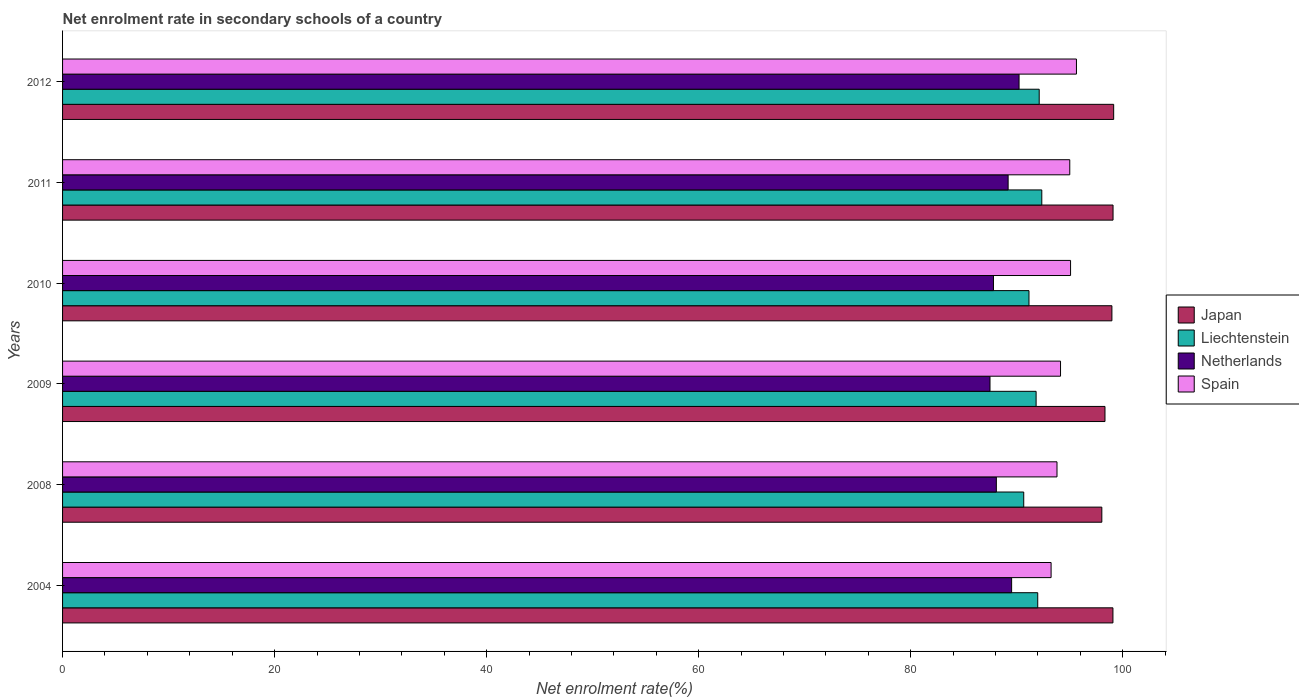How many different coloured bars are there?
Keep it short and to the point. 4. Are the number of bars per tick equal to the number of legend labels?
Ensure brevity in your answer.  Yes. How many bars are there on the 6th tick from the top?
Offer a terse response. 4. In how many cases, is the number of bars for a given year not equal to the number of legend labels?
Provide a short and direct response. 0. What is the net enrolment rate in secondary schools in Spain in 2008?
Give a very brief answer. 93.8. Across all years, what is the maximum net enrolment rate in secondary schools in Liechtenstein?
Make the answer very short. 92.36. Across all years, what is the minimum net enrolment rate in secondary schools in Netherlands?
Your answer should be very brief. 87.48. In which year was the net enrolment rate in secondary schools in Liechtenstein maximum?
Your answer should be compact. 2011. What is the total net enrolment rate in secondary schools in Netherlands in the graph?
Provide a short and direct response. 532.28. What is the difference between the net enrolment rate in secondary schools in Netherlands in 2009 and that in 2010?
Provide a succinct answer. -0.33. What is the difference between the net enrolment rate in secondary schools in Spain in 2004 and the net enrolment rate in secondary schools in Japan in 2011?
Your response must be concise. -5.84. What is the average net enrolment rate in secondary schools in Spain per year?
Offer a terse response. 94.48. In the year 2012, what is the difference between the net enrolment rate in secondary schools in Japan and net enrolment rate in secondary schools in Liechtenstein?
Provide a short and direct response. 7.02. What is the ratio of the net enrolment rate in secondary schools in Spain in 2004 to that in 2010?
Ensure brevity in your answer.  0.98. What is the difference between the highest and the second highest net enrolment rate in secondary schools in Liechtenstein?
Your answer should be very brief. 0.24. What is the difference between the highest and the lowest net enrolment rate in secondary schools in Netherlands?
Provide a short and direct response. 2.74. In how many years, is the net enrolment rate in secondary schools in Japan greater than the average net enrolment rate in secondary schools in Japan taken over all years?
Your answer should be compact. 4. Is it the case that in every year, the sum of the net enrolment rate in secondary schools in Japan and net enrolment rate in secondary schools in Liechtenstein is greater than the sum of net enrolment rate in secondary schools in Netherlands and net enrolment rate in secondary schools in Spain?
Make the answer very short. Yes. What does the 2nd bar from the bottom in 2010 represents?
Provide a succinct answer. Liechtenstein. Is it the case that in every year, the sum of the net enrolment rate in secondary schools in Liechtenstein and net enrolment rate in secondary schools in Spain is greater than the net enrolment rate in secondary schools in Japan?
Provide a succinct answer. Yes. How many bars are there?
Offer a terse response. 24. Are all the bars in the graph horizontal?
Provide a short and direct response. Yes. How many years are there in the graph?
Your answer should be very brief. 6. Are the values on the major ticks of X-axis written in scientific E-notation?
Provide a succinct answer. No. Does the graph contain any zero values?
Provide a short and direct response. No. Does the graph contain grids?
Keep it short and to the point. No. What is the title of the graph?
Your answer should be compact. Net enrolment rate in secondary schools of a country. What is the label or title of the X-axis?
Give a very brief answer. Net enrolment rate(%). What is the Net enrolment rate(%) of Japan in 2004?
Provide a succinct answer. 99.07. What is the Net enrolment rate(%) in Liechtenstein in 2004?
Provide a succinct answer. 91.98. What is the Net enrolment rate(%) in Netherlands in 2004?
Keep it short and to the point. 89.52. What is the Net enrolment rate(%) of Spain in 2004?
Ensure brevity in your answer.  93.24. What is the Net enrolment rate(%) in Japan in 2008?
Offer a terse response. 98.03. What is the Net enrolment rate(%) of Liechtenstein in 2008?
Give a very brief answer. 90.66. What is the Net enrolment rate(%) of Netherlands in 2008?
Offer a terse response. 88.08. What is the Net enrolment rate(%) in Spain in 2008?
Make the answer very short. 93.8. What is the Net enrolment rate(%) of Japan in 2009?
Keep it short and to the point. 98.32. What is the Net enrolment rate(%) of Liechtenstein in 2009?
Offer a terse response. 91.83. What is the Net enrolment rate(%) of Netherlands in 2009?
Keep it short and to the point. 87.48. What is the Net enrolment rate(%) of Spain in 2009?
Make the answer very short. 94.13. What is the Net enrolment rate(%) of Japan in 2010?
Provide a short and direct response. 98.98. What is the Net enrolment rate(%) of Liechtenstein in 2010?
Your answer should be compact. 91.15. What is the Net enrolment rate(%) in Netherlands in 2010?
Provide a short and direct response. 87.8. What is the Net enrolment rate(%) in Spain in 2010?
Keep it short and to the point. 95.08. What is the Net enrolment rate(%) of Japan in 2011?
Provide a short and direct response. 99.08. What is the Net enrolment rate(%) of Liechtenstein in 2011?
Make the answer very short. 92.36. What is the Net enrolment rate(%) in Netherlands in 2011?
Ensure brevity in your answer.  89.19. What is the Net enrolment rate(%) in Spain in 2011?
Your answer should be very brief. 95. What is the Net enrolment rate(%) of Japan in 2012?
Your response must be concise. 99.14. What is the Net enrolment rate(%) in Liechtenstein in 2012?
Give a very brief answer. 92.12. What is the Net enrolment rate(%) in Netherlands in 2012?
Give a very brief answer. 90.22. What is the Net enrolment rate(%) in Spain in 2012?
Provide a short and direct response. 95.63. Across all years, what is the maximum Net enrolment rate(%) in Japan?
Keep it short and to the point. 99.14. Across all years, what is the maximum Net enrolment rate(%) in Liechtenstein?
Your answer should be very brief. 92.36. Across all years, what is the maximum Net enrolment rate(%) in Netherlands?
Give a very brief answer. 90.22. Across all years, what is the maximum Net enrolment rate(%) of Spain?
Offer a terse response. 95.63. Across all years, what is the minimum Net enrolment rate(%) in Japan?
Ensure brevity in your answer.  98.03. Across all years, what is the minimum Net enrolment rate(%) in Liechtenstein?
Your answer should be very brief. 90.66. Across all years, what is the minimum Net enrolment rate(%) in Netherlands?
Your answer should be compact. 87.48. Across all years, what is the minimum Net enrolment rate(%) in Spain?
Your answer should be compact. 93.24. What is the total Net enrolment rate(%) of Japan in the graph?
Keep it short and to the point. 592.62. What is the total Net enrolment rate(%) in Liechtenstein in the graph?
Your answer should be compact. 550.1. What is the total Net enrolment rate(%) of Netherlands in the graph?
Provide a short and direct response. 532.28. What is the total Net enrolment rate(%) in Spain in the graph?
Your response must be concise. 566.88. What is the difference between the Net enrolment rate(%) of Japan in 2004 and that in 2008?
Make the answer very short. 1.05. What is the difference between the Net enrolment rate(%) of Liechtenstein in 2004 and that in 2008?
Your response must be concise. 1.32. What is the difference between the Net enrolment rate(%) of Netherlands in 2004 and that in 2008?
Make the answer very short. 1.44. What is the difference between the Net enrolment rate(%) in Spain in 2004 and that in 2008?
Ensure brevity in your answer.  -0.56. What is the difference between the Net enrolment rate(%) in Japan in 2004 and that in 2009?
Your response must be concise. 0.75. What is the difference between the Net enrolment rate(%) of Liechtenstein in 2004 and that in 2009?
Provide a succinct answer. 0.15. What is the difference between the Net enrolment rate(%) in Netherlands in 2004 and that in 2009?
Offer a terse response. 2.04. What is the difference between the Net enrolment rate(%) of Spain in 2004 and that in 2009?
Make the answer very short. -0.89. What is the difference between the Net enrolment rate(%) in Japan in 2004 and that in 2010?
Your response must be concise. 0.1. What is the difference between the Net enrolment rate(%) in Liechtenstein in 2004 and that in 2010?
Your answer should be very brief. 0.83. What is the difference between the Net enrolment rate(%) in Netherlands in 2004 and that in 2010?
Provide a short and direct response. 1.71. What is the difference between the Net enrolment rate(%) of Spain in 2004 and that in 2010?
Your answer should be very brief. -1.84. What is the difference between the Net enrolment rate(%) in Japan in 2004 and that in 2011?
Your response must be concise. -0.01. What is the difference between the Net enrolment rate(%) of Liechtenstein in 2004 and that in 2011?
Ensure brevity in your answer.  -0.38. What is the difference between the Net enrolment rate(%) in Netherlands in 2004 and that in 2011?
Your answer should be very brief. 0.33. What is the difference between the Net enrolment rate(%) in Spain in 2004 and that in 2011?
Your answer should be very brief. -1.76. What is the difference between the Net enrolment rate(%) in Japan in 2004 and that in 2012?
Keep it short and to the point. -0.07. What is the difference between the Net enrolment rate(%) in Liechtenstein in 2004 and that in 2012?
Make the answer very short. -0.14. What is the difference between the Net enrolment rate(%) in Netherlands in 2004 and that in 2012?
Your answer should be very brief. -0.7. What is the difference between the Net enrolment rate(%) of Spain in 2004 and that in 2012?
Offer a very short reply. -2.39. What is the difference between the Net enrolment rate(%) of Japan in 2008 and that in 2009?
Keep it short and to the point. -0.3. What is the difference between the Net enrolment rate(%) of Liechtenstein in 2008 and that in 2009?
Your response must be concise. -1.17. What is the difference between the Net enrolment rate(%) in Netherlands in 2008 and that in 2009?
Provide a succinct answer. 0.6. What is the difference between the Net enrolment rate(%) of Spain in 2008 and that in 2009?
Provide a short and direct response. -0.33. What is the difference between the Net enrolment rate(%) in Japan in 2008 and that in 2010?
Your response must be concise. -0.95. What is the difference between the Net enrolment rate(%) of Liechtenstein in 2008 and that in 2010?
Ensure brevity in your answer.  -0.49. What is the difference between the Net enrolment rate(%) in Netherlands in 2008 and that in 2010?
Keep it short and to the point. 0.27. What is the difference between the Net enrolment rate(%) in Spain in 2008 and that in 2010?
Offer a terse response. -1.28. What is the difference between the Net enrolment rate(%) in Japan in 2008 and that in 2011?
Offer a very short reply. -1.06. What is the difference between the Net enrolment rate(%) in Liechtenstein in 2008 and that in 2011?
Give a very brief answer. -1.7. What is the difference between the Net enrolment rate(%) of Netherlands in 2008 and that in 2011?
Ensure brevity in your answer.  -1.11. What is the difference between the Net enrolment rate(%) in Spain in 2008 and that in 2011?
Make the answer very short. -1.21. What is the difference between the Net enrolment rate(%) in Japan in 2008 and that in 2012?
Your answer should be compact. -1.12. What is the difference between the Net enrolment rate(%) of Liechtenstein in 2008 and that in 2012?
Your answer should be very brief. -1.46. What is the difference between the Net enrolment rate(%) of Netherlands in 2008 and that in 2012?
Give a very brief answer. -2.14. What is the difference between the Net enrolment rate(%) of Spain in 2008 and that in 2012?
Ensure brevity in your answer.  -1.84. What is the difference between the Net enrolment rate(%) in Japan in 2009 and that in 2010?
Your answer should be very brief. -0.65. What is the difference between the Net enrolment rate(%) in Liechtenstein in 2009 and that in 2010?
Ensure brevity in your answer.  0.67. What is the difference between the Net enrolment rate(%) of Netherlands in 2009 and that in 2010?
Offer a terse response. -0.33. What is the difference between the Net enrolment rate(%) in Spain in 2009 and that in 2010?
Provide a succinct answer. -0.95. What is the difference between the Net enrolment rate(%) in Japan in 2009 and that in 2011?
Make the answer very short. -0.76. What is the difference between the Net enrolment rate(%) in Liechtenstein in 2009 and that in 2011?
Make the answer very short. -0.54. What is the difference between the Net enrolment rate(%) in Netherlands in 2009 and that in 2011?
Ensure brevity in your answer.  -1.71. What is the difference between the Net enrolment rate(%) in Spain in 2009 and that in 2011?
Your answer should be very brief. -0.87. What is the difference between the Net enrolment rate(%) in Japan in 2009 and that in 2012?
Give a very brief answer. -0.82. What is the difference between the Net enrolment rate(%) in Liechtenstein in 2009 and that in 2012?
Keep it short and to the point. -0.29. What is the difference between the Net enrolment rate(%) in Netherlands in 2009 and that in 2012?
Keep it short and to the point. -2.74. What is the difference between the Net enrolment rate(%) of Spain in 2009 and that in 2012?
Provide a succinct answer. -1.5. What is the difference between the Net enrolment rate(%) in Japan in 2010 and that in 2011?
Your answer should be compact. -0.11. What is the difference between the Net enrolment rate(%) of Liechtenstein in 2010 and that in 2011?
Provide a short and direct response. -1.21. What is the difference between the Net enrolment rate(%) of Netherlands in 2010 and that in 2011?
Make the answer very short. -1.38. What is the difference between the Net enrolment rate(%) of Spain in 2010 and that in 2011?
Make the answer very short. 0.07. What is the difference between the Net enrolment rate(%) in Japan in 2010 and that in 2012?
Provide a succinct answer. -0.17. What is the difference between the Net enrolment rate(%) in Liechtenstein in 2010 and that in 2012?
Ensure brevity in your answer.  -0.96. What is the difference between the Net enrolment rate(%) of Netherlands in 2010 and that in 2012?
Your response must be concise. -2.41. What is the difference between the Net enrolment rate(%) of Spain in 2010 and that in 2012?
Your response must be concise. -0.56. What is the difference between the Net enrolment rate(%) of Japan in 2011 and that in 2012?
Your answer should be very brief. -0.06. What is the difference between the Net enrolment rate(%) of Liechtenstein in 2011 and that in 2012?
Make the answer very short. 0.24. What is the difference between the Net enrolment rate(%) in Netherlands in 2011 and that in 2012?
Provide a short and direct response. -1.03. What is the difference between the Net enrolment rate(%) in Spain in 2011 and that in 2012?
Keep it short and to the point. -0.63. What is the difference between the Net enrolment rate(%) in Japan in 2004 and the Net enrolment rate(%) in Liechtenstein in 2008?
Provide a short and direct response. 8.41. What is the difference between the Net enrolment rate(%) of Japan in 2004 and the Net enrolment rate(%) of Netherlands in 2008?
Provide a short and direct response. 11. What is the difference between the Net enrolment rate(%) in Japan in 2004 and the Net enrolment rate(%) in Spain in 2008?
Ensure brevity in your answer.  5.28. What is the difference between the Net enrolment rate(%) of Liechtenstein in 2004 and the Net enrolment rate(%) of Netherlands in 2008?
Provide a succinct answer. 3.9. What is the difference between the Net enrolment rate(%) of Liechtenstein in 2004 and the Net enrolment rate(%) of Spain in 2008?
Keep it short and to the point. -1.82. What is the difference between the Net enrolment rate(%) of Netherlands in 2004 and the Net enrolment rate(%) of Spain in 2008?
Your answer should be very brief. -4.28. What is the difference between the Net enrolment rate(%) of Japan in 2004 and the Net enrolment rate(%) of Liechtenstein in 2009?
Your response must be concise. 7.25. What is the difference between the Net enrolment rate(%) of Japan in 2004 and the Net enrolment rate(%) of Netherlands in 2009?
Provide a succinct answer. 11.6. What is the difference between the Net enrolment rate(%) in Japan in 2004 and the Net enrolment rate(%) in Spain in 2009?
Provide a succinct answer. 4.94. What is the difference between the Net enrolment rate(%) in Liechtenstein in 2004 and the Net enrolment rate(%) in Netherlands in 2009?
Give a very brief answer. 4.5. What is the difference between the Net enrolment rate(%) of Liechtenstein in 2004 and the Net enrolment rate(%) of Spain in 2009?
Give a very brief answer. -2.15. What is the difference between the Net enrolment rate(%) of Netherlands in 2004 and the Net enrolment rate(%) of Spain in 2009?
Make the answer very short. -4.61. What is the difference between the Net enrolment rate(%) of Japan in 2004 and the Net enrolment rate(%) of Liechtenstein in 2010?
Your response must be concise. 7.92. What is the difference between the Net enrolment rate(%) of Japan in 2004 and the Net enrolment rate(%) of Netherlands in 2010?
Your answer should be compact. 11.27. What is the difference between the Net enrolment rate(%) of Japan in 2004 and the Net enrolment rate(%) of Spain in 2010?
Your answer should be very brief. 4. What is the difference between the Net enrolment rate(%) in Liechtenstein in 2004 and the Net enrolment rate(%) in Netherlands in 2010?
Provide a succinct answer. 4.18. What is the difference between the Net enrolment rate(%) in Liechtenstein in 2004 and the Net enrolment rate(%) in Spain in 2010?
Offer a very short reply. -3.1. What is the difference between the Net enrolment rate(%) in Netherlands in 2004 and the Net enrolment rate(%) in Spain in 2010?
Your response must be concise. -5.56. What is the difference between the Net enrolment rate(%) of Japan in 2004 and the Net enrolment rate(%) of Liechtenstein in 2011?
Ensure brevity in your answer.  6.71. What is the difference between the Net enrolment rate(%) in Japan in 2004 and the Net enrolment rate(%) in Netherlands in 2011?
Your response must be concise. 9.89. What is the difference between the Net enrolment rate(%) of Japan in 2004 and the Net enrolment rate(%) of Spain in 2011?
Provide a succinct answer. 4.07. What is the difference between the Net enrolment rate(%) in Liechtenstein in 2004 and the Net enrolment rate(%) in Netherlands in 2011?
Your answer should be compact. 2.79. What is the difference between the Net enrolment rate(%) in Liechtenstein in 2004 and the Net enrolment rate(%) in Spain in 2011?
Provide a succinct answer. -3.02. What is the difference between the Net enrolment rate(%) of Netherlands in 2004 and the Net enrolment rate(%) of Spain in 2011?
Provide a short and direct response. -5.48. What is the difference between the Net enrolment rate(%) in Japan in 2004 and the Net enrolment rate(%) in Liechtenstein in 2012?
Provide a succinct answer. 6.96. What is the difference between the Net enrolment rate(%) of Japan in 2004 and the Net enrolment rate(%) of Netherlands in 2012?
Make the answer very short. 8.86. What is the difference between the Net enrolment rate(%) of Japan in 2004 and the Net enrolment rate(%) of Spain in 2012?
Ensure brevity in your answer.  3.44. What is the difference between the Net enrolment rate(%) of Liechtenstein in 2004 and the Net enrolment rate(%) of Netherlands in 2012?
Your answer should be compact. 1.76. What is the difference between the Net enrolment rate(%) of Liechtenstein in 2004 and the Net enrolment rate(%) of Spain in 2012?
Your answer should be compact. -3.65. What is the difference between the Net enrolment rate(%) in Netherlands in 2004 and the Net enrolment rate(%) in Spain in 2012?
Keep it short and to the point. -6.11. What is the difference between the Net enrolment rate(%) in Japan in 2008 and the Net enrolment rate(%) in Liechtenstein in 2009?
Offer a terse response. 6.2. What is the difference between the Net enrolment rate(%) in Japan in 2008 and the Net enrolment rate(%) in Netherlands in 2009?
Provide a succinct answer. 10.55. What is the difference between the Net enrolment rate(%) in Japan in 2008 and the Net enrolment rate(%) in Spain in 2009?
Offer a very short reply. 3.9. What is the difference between the Net enrolment rate(%) of Liechtenstein in 2008 and the Net enrolment rate(%) of Netherlands in 2009?
Provide a succinct answer. 3.18. What is the difference between the Net enrolment rate(%) in Liechtenstein in 2008 and the Net enrolment rate(%) in Spain in 2009?
Keep it short and to the point. -3.47. What is the difference between the Net enrolment rate(%) in Netherlands in 2008 and the Net enrolment rate(%) in Spain in 2009?
Give a very brief answer. -6.05. What is the difference between the Net enrolment rate(%) of Japan in 2008 and the Net enrolment rate(%) of Liechtenstein in 2010?
Your answer should be very brief. 6.87. What is the difference between the Net enrolment rate(%) in Japan in 2008 and the Net enrolment rate(%) in Netherlands in 2010?
Ensure brevity in your answer.  10.22. What is the difference between the Net enrolment rate(%) in Japan in 2008 and the Net enrolment rate(%) in Spain in 2010?
Provide a succinct answer. 2.95. What is the difference between the Net enrolment rate(%) of Liechtenstein in 2008 and the Net enrolment rate(%) of Netherlands in 2010?
Make the answer very short. 2.86. What is the difference between the Net enrolment rate(%) in Liechtenstein in 2008 and the Net enrolment rate(%) in Spain in 2010?
Your response must be concise. -4.42. What is the difference between the Net enrolment rate(%) in Netherlands in 2008 and the Net enrolment rate(%) in Spain in 2010?
Offer a terse response. -7. What is the difference between the Net enrolment rate(%) in Japan in 2008 and the Net enrolment rate(%) in Liechtenstein in 2011?
Your response must be concise. 5.66. What is the difference between the Net enrolment rate(%) in Japan in 2008 and the Net enrolment rate(%) in Netherlands in 2011?
Give a very brief answer. 8.84. What is the difference between the Net enrolment rate(%) in Japan in 2008 and the Net enrolment rate(%) in Spain in 2011?
Your response must be concise. 3.02. What is the difference between the Net enrolment rate(%) of Liechtenstein in 2008 and the Net enrolment rate(%) of Netherlands in 2011?
Provide a short and direct response. 1.47. What is the difference between the Net enrolment rate(%) in Liechtenstein in 2008 and the Net enrolment rate(%) in Spain in 2011?
Offer a very short reply. -4.34. What is the difference between the Net enrolment rate(%) of Netherlands in 2008 and the Net enrolment rate(%) of Spain in 2011?
Provide a succinct answer. -6.93. What is the difference between the Net enrolment rate(%) in Japan in 2008 and the Net enrolment rate(%) in Liechtenstein in 2012?
Offer a very short reply. 5.91. What is the difference between the Net enrolment rate(%) in Japan in 2008 and the Net enrolment rate(%) in Netherlands in 2012?
Your answer should be very brief. 7.81. What is the difference between the Net enrolment rate(%) of Japan in 2008 and the Net enrolment rate(%) of Spain in 2012?
Give a very brief answer. 2.39. What is the difference between the Net enrolment rate(%) in Liechtenstein in 2008 and the Net enrolment rate(%) in Netherlands in 2012?
Offer a terse response. 0.44. What is the difference between the Net enrolment rate(%) of Liechtenstein in 2008 and the Net enrolment rate(%) of Spain in 2012?
Offer a very short reply. -4.97. What is the difference between the Net enrolment rate(%) of Netherlands in 2008 and the Net enrolment rate(%) of Spain in 2012?
Your answer should be very brief. -7.56. What is the difference between the Net enrolment rate(%) in Japan in 2009 and the Net enrolment rate(%) in Liechtenstein in 2010?
Offer a terse response. 7.17. What is the difference between the Net enrolment rate(%) in Japan in 2009 and the Net enrolment rate(%) in Netherlands in 2010?
Provide a short and direct response. 10.52. What is the difference between the Net enrolment rate(%) of Japan in 2009 and the Net enrolment rate(%) of Spain in 2010?
Give a very brief answer. 3.25. What is the difference between the Net enrolment rate(%) of Liechtenstein in 2009 and the Net enrolment rate(%) of Netherlands in 2010?
Your answer should be compact. 4.02. What is the difference between the Net enrolment rate(%) of Liechtenstein in 2009 and the Net enrolment rate(%) of Spain in 2010?
Your answer should be compact. -3.25. What is the difference between the Net enrolment rate(%) of Netherlands in 2009 and the Net enrolment rate(%) of Spain in 2010?
Ensure brevity in your answer.  -7.6. What is the difference between the Net enrolment rate(%) in Japan in 2009 and the Net enrolment rate(%) in Liechtenstein in 2011?
Provide a short and direct response. 5.96. What is the difference between the Net enrolment rate(%) of Japan in 2009 and the Net enrolment rate(%) of Netherlands in 2011?
Keep it short and to the point. 9.14. What is the difference between the Net enrolment rate(%) in Japan in 2009 and the Net enrolment rate(%) in Spain in 2011?
Keep it short and to the point. 3.32. What is the difference between the Net enrolment rate(%) in Liechtenstein in 2009 and the Net enrolment rate(%) in Netherlands in 2011?
Keep it short and to the point. 2.64. What is the difference between the Net enrolment rate(%) of Liechtenstein in 2009 and the Net enrolment rate(%) of Spain in 2011?
Keep it short and to the point. -3.18. What is the difference between the Net enrolment rate(%) in Netherlands in 2009 and the Net enrolment rate(%) in Spain in 2011?
Your answer should be very brief. -7.52. What is the difference between the Net enrolment rate(%) of Japan in 2009 and the Net enrolment rate(%) of Liechtenstein in 2012?
Provide a succinct answer. 6.2. What is the difference between the Net enrolment rate(%) of Japan in 2009 and the Net enrolment rate(%) of Netherlands in 2012?
Make the answer very short. 8.1. What is the difference between the Net enrolment rate(%) of Japan in 2009 and the Net enrolment rate(%) of Spain in 2012?
Offer a terse response. 2.69. What is the difference between the Net enrolment rate(%) in Liechtenstein in 2009 and the Net enrolment rate(%) in Netherlands in 2012?
Give a very brief answer. 1.61. What is the difference between the Net enrolment rate(%) in Liechtenstein in 2009 and the Net enrolment rate(%) in Spain in 2012?
Your answer should be very brief. -3.81. What is the difference between the Net enrolment rate(%) in Netherlands in 2009 and the Net enrolment rate(%) in Spain in 2012?
Your answer should be compact. -8.15. What is the difference between the Net enrolment rate(%) of Japan in 2010 and the Net enrolment rate(%) of Liechtenstein in 2011?
Ensure brevity in your answer.  6.61. What is the difference between the Net enrolment rate(%) in Japan in 2010 and the Net enrolment rate(%) in Netherlands in 2011?
Keep it short and to the point. 9.79. What is the difference between the Net enrolment rate(%) of Japan in 2010 and the Net enrolment rate(%) of Spain in 2011?
Your answer should be very brief. 3.97. What is the difference between the Net enrolment rate(%) of Liechtenstein in 2010 and the Net enrolment rate(%) of Netherlands in 2011?
Keep it short and to the point. 1.97. What is the difference between the Net enrolment rate(%) in Liechtenstein in 2010 and the Net enrolment rate(%) in Spain in 2011?
Provide a short and direct response. -3.85. What is the difference between the Net enrolment rate(%) of Netherlands in 2010 and the Net enrolment rate(%) of Spain in 2011?
Provide a succinct answer. -7.2. What is the difference between the Net enrolment rate(%) in Japan in 2010 and the Net enrolment rate(%) in Liechtenstein in 2012?
Your response must be concise. 6.86. What is the difference between the Net enrolment rate(%) in Japan in 2010 and the Net enrolment rate(%) in Netherlands in 2012?
Your answer should be very brief. 8.76. What is the difference between the Net enrolment rate(%) in Japan in 2010 and the Net enrolment rate(%) in Spain in 2012?
Ensure brevity in your answer.  3.34. What is the difference between the Net enrolment rate(%) of Liechtenstein in 2010 and the Net enrolment rate(%) of Netherlands in 2012?
Ensure brevity in your answer.  0.94. What is the difference between the Net enrolment rate(%) of Liechtenstein in 2010 and the Net enrolment rate(%) of Spain in 2012?
Ensure brevity in your answer.  -4.48. What is the difference between the Net enrolment rate(%) in Netherlands in 2010 and the Net enrolment rate(%) in Spain in 2012?
Give a very brief answer. -7.83. What is the difference between the Net enrolment rate(%) of Japan in 2011 and the Net enrolment rate(%) of Liechtenstein in 2012?
Make the answer very short. 6.96. What is the difference between the Net enrolment rate(%) in Japan in 2011 and the Net enrolment rate(%) in Netherlands in 2012?
Ensure brevity in your answer.  8.87. What is the difference between the Net enrolment rate(%) of Japan in 2011 and the Net enrolment rate(%) of Spain in 2012?
Keep it short and to the point. 3.45. What is the difference between the Net enrolment rate(%) in Liechtenstein in 2011 and the Net enrolment rate(%) in Netherlands in 2012?
Your answer should be very brief. 2.14. What is the difference between the Net enrolment rate(%) of Liechtenstein in 2011 and the Net enrolment rate(%) of Spain in 2012?
Your answer should be compact. -3.27. What is the difference between the Net enrolment rate(%) in Netherlands in 2011 and the Net enrolment rate(%) in Spain in 2012?
Give a very brief answer. -6.45. What is the average Net enrolment rate(%) of Japan per year?
Offer a very short reply. 98.77. What is the average Net enrolment rate(%) in Liechtenstein per year?
Offer a terse response. 91.68. What is the average Net enrolment rate(%) of Netherlands per year?
Provide a short and direct response. 88.71. What is the average Net enrolment rate(%) in Spain per year?
Offer a terse response. 94.48. In the year 2004, what is the difference between the Net enrolment rate(%) of Japan and Net enrolment rate(%) of Liechtenstein?
Keep it short and to the point. 7.09. In the year 2004, what is the difference between the Net enrolment rate(%) in Japan and Net enrolment rate(%) in Netherlands?
Ensure brevity in your answer.  9.56. In the year 2004, what is the difference between the Net enrolment rate(%) of Japan and Net enrolment rate(%) of Spain?
Ensure brevity in your answer.  5.83. In the year 2004, what is the difference between the Net enrolment rate(%) in Liechtenstein and Net enrolment rate(%) in Netherlands?
Offer a very short reply. 2.46. In the year 2004, what is the difference between the Net enrolment rate(%) in Liechtenstein and Net enrolment rate(%) in Spain?
Your answer should be compact. -1.26. In the year 2004, what is the difference between the Net enrolment rate(%) of Netherlands and Net enrolment rate(%) of Spain?
Offer a very short reply. -3.72. In the year 2008, what is the difference between the Net enrolment rate(%) in Japan and Net enrolment rate(%) in Liechtenstein?
Your answer should be compact. 7.37. In the year 2008, what is the difference between the Net enrolment rate(%) in Japan and Net enrolment rate(%) in Netherlands?
Give a very brief answer. 9.95. In the year 2008, what is the difference between the Net enrolment rate(%) of Japan and Net enrolment rate(%) of Spain?
Your answer should be compact. 4.23. In the year 2008, what is the difference between the Net enrolment rate(%) in Liechtenstein and Net enrolment rate(%) in Netherlands?
Your answer should be compact. 2.58. In the year 2008, what is the difference between the Net enrolment rate(%) in Liechtenstein and Net enrolment rate(%) in Spain?
Keep it short and to the point. -3.14. In the year 2008, what is the difference between the Net enrolment rate(%) of Netherlands and Net enrolment rate(%) of Spain?
Your answer should be very brief. -5.72. In the year 2009, what is the difference between the Net enrolment rate(%) of Japan and Net enrolment rate(%) of Liechtenstein?
Offer a terse response. 6.5. In the year 2009, what is the difference between the Net enrolment rate(%) in Japan and Net enrolment rate(%) in Netherlands?
Provide a succinct answer. 10.84. In the year 2009, what is the difference between the Net enrolment rate(%) of Japan and Net enrolment rate(%) of Spain?
Offer a very short reply. 4.19. In the year 2009, what is the difference between the Net enrolment rate(%) of Liechtenstein and Net enrolment rate(%) of Netherlands?
Make the answer very short. 4.35. In the year 2009, what is the difference between the Net enrolment rate(%) of Liechtenstein and Net enrolment rate(%) of Spain?
Keep it short and to the point. -2.3. In the year 2009, what is the difference between the Net enrolment rate(%) in Netherlands and Net enrolment rate(%) in Spain?
Make the answer very short. -6.65. In the year 2010, what is the difference between the Net enrolment rate(%) of Japan and Net enrolment rate(%) of Liechtenstein?
Provide a succinct answer. 7.82. In the year 2010, what is the difference between the Net enrolment rate(%) of Japan and Net enrolment rate(%) of Netherlands?
Your response must be concise. 11.17. In the year 2010, what is the difference between the Net enrolment rate(%) in Japan and Net enrolment rate(%) in Spain?
Your answer should be compact. 3.9. In the year 2010, what is the difference between the Net enrolment rate(%) of Liechtenstein and Net enrolment rate(%) of Netherlands?
Provide a succinct answer. 3.35. In the year 2010, what is the difference between the Net enrolment rate(%) in Liechtenstein and Net enrolment rate(%) in Spain?
Offer a very short reply. -3.92. In the year 2010, what is the difference between the Net enrolment rate(%) of Netherlands and Net enrolment rate(%) of Spain?
Keep it short and to the point. -7.27. In the year 2011, what is the difference between the Net enrolment rate(%) of Japan and Net enrolment rate(%) of Liechtenstein?
Ensure brevity in your answer.  6.72. In the year 2011, what is the difference between the Net enrolment rate(%) of Japan and Net enrolment rate(%) of Netherlands?
Make the answer very short. 9.9. In the year 2011, what is the difference between the Net enrolment rate(%) in Japan and Net enrolment rate(%) in Spain?
Your response must be concise. 4.08. In the year 2011, what is the difference between the Net enrolment rate(%) in Liechtenstein and Net enrolment rate(%) in Netherlands?
Make the answer very short. 3.17. In the year 2011, what is the difference between the Net enrolment rate(%) of Liechtenstein and Net enrolment rate(%) of Spain?
Provide a succinct answer. -2.64. In the year 2011, what is the difference between the Net enrolment rate(%) of Netherlands and Net enrolment rate(%) of Spain?
Make the answer very short. -5.81. In the year 2012, what is the difference between the Net enrolment rate(%) in Japan and Net enrolment rate(%) in Liechtenstein?
Your answer should be very brief. 7.02. In the year 2012, what is the difference between the Net enrolment rate(%) in Japan and Net enrolment rate(%) in Netherlands?
Your response must be concise. 8.92. In the year 2012, what is the difference between the Net enrolment rate(%) in Japan and Net enrolment rate(%) in Spain?
Your answer should be compact. 3.51. In the year 2012, what is the difference between the Net enrolment rate(%) in Liechtenstein and Net enrolment rate(%) in Netherlands?
Your answer should be very brief. 1.9. In the year 2012, what is the difference between the Net enrolment rate(%) of Liechtenstein and Net enrolment rate(%) of Spain?
Give a very brief answer. -3.51. In the year 2012, what is the difference between the Net enrolment rate(%) in Netherlands and Net enrolment rate(%) in Spain?
Offer a terse response. -5.41. What is the ratio of the Net enrolment rate(%) in Japan in 2004 to that in 2008?
Make the answer very short. 1.01. What is the ratio of the Net enrolment rate(%) in Liechtenstein in 2004 to that in 2008?
Make the answer very short. 1.01. What is the ratio of the Net enrolment rate(%) of Netherlands in 2004 to that in 2008?
Keep it short and to the point. 1.02. What is the ratio of the Net enrolment rate(%) in Japan in 2004 to that in 2009?
Your answer should be very brief. 1.01. What is the ratio of the Net enrolment rate(%) of Netherlands in 2004 to that in 2009?
Offer a very short reply. 1.02. What is the ratio of the Net enrolment rate(%) in Spain in 2004 to that in 2009?
Provide a succinct answer. 0.99. What is the ratio of the Net enrolment rate(%) in Japan in 2004 to that in 2010?
Offer a very short reply. 1. What is the ratio of the Net enrolment rate(%) in Liechtenstein in 2004 to that in 2010?
Your answer should be very brief. 1.01. What is the ratio of the Net enrolment rate(%) in Netherlands in 2004 to that in 2010?
Make the answer very short. 1.02. What is the ratio of the Net enrolment rate(%) of Spain in 2004 to that in 2010?
Offer a terse response. 0.98. What is the ratio of the Net enrolment rate(%) of Japan in 2004 to that in 2011?
Your response must be concise. 1. What is the ratio of the Net enrolment rate(%) of Netherlands in 2004 to that in 2011?
Your answer should be very brief. 1. What is the ratio of the Net enrolment rate(%) of Spain in 2004 to that in 2011?
Offer a very short reply. 0.98. What is the ratio of the Net enrolment rate(%) of Liechtenstein in 2008 to that in 2009?
Provide a succinct answer. 0.99. What is the ratio of the Net enrolment rate(%) of Netherlands in 2008 to that in 2009?
Your answer should be compact. 1.01. What is the ratio of the Net enrolment rate(%) of Liechtenstein in 2008 to that in 2010?
Give a very brief answer. 0.99. What is the ratio of the Net enrolment rate(%) in Spain in 2008 to that in 2010?
Make the answer very short. 0.99. What is the ratio of the Net enrolment rate(%) in Japan in 2008 to that in 2011?
Keep it short and to the point. 0.99. What is the ratio of the Net enrolment rate(%) of Liechtenstein in 2008 to that in 2011?
Keep it short and to the point. 0.98. What is the ratio of the Net enrolment rate(%) in Netherlands in 2008 to that in 2011?
Your answer should be very brief. 0.99. What is the ratio of the Net enrolment rate(%) of Spain in 2008 to that in 2011?
Your answer should be very brief. 0.99. What is the ratio of the Net enrolment rate(%) in Japan in 2008 to that in 2012?
Provide a succinct answer. 0.99. What is the ratio of the Net enrolment rate(%) in Liechtenstein in 2008 to that in 2012?
Keep it short and to the point. 0.98. What is the ratio of the Net enrolment rate(%) of Netherlands in 2008 to that in 2012?
Give a very brief answer. 0.98. What is the ratio of the Net enrolment rate(%) of Spain in 2008 to that in 2012?
Ensure brevity in your answer.  0.98. What is the ratio of the Net enrolment rate(%) in Japan in 2009 to that in 2010?
Ensure brevity in your answer.  0.99. What is the ratio of the Net enrolment rate(%) in Liechtenstein in 2009 to that in 2010?
Your response must be concise. 1.01. What is the ratio of the Net enrolment rate(%) of Netherlands in 2009 to that in 2010?
Offer a very short reply. 1. What is the ratio of the Net enrolment rate(%) in Japan in 2009 to that in 2011?
Keep it short and to the point. 0.99. What is the ratio of the Net enrolment rate(%) of Netherlands in 2009 to that in 2011?
Your answer should be compact. 0.98. What is the ratio of the Net enrolment rate(%) of Japan in 2009 to that in 2012?
Give a very brief answer. 0.99. What is the ratio of the Net enrolment rate(%) of Liechtenstein in 2009 to that in 2012?
Your answer should be compact. 1. What is the ratio of the Net enrolment rate(%) in Netherlands in 2009 to that in 2012?
Ensure brevity in your answer.  0.97. What is the ratio of the Net enrolment rate(%) of Spain in 2009 to that in 2012?
Your answer should be compact. 0.98. What is the ratio of the Net enrolment rate(%) in Japan in 2010 to that in 2011?
Provide a short and direct response. 1. What is the ratio of the Net enrolment rate(%) of Liechtenstein in 2010 to that in 2011?
Offer a terse response. 0.99. What is the ratio of the Net enrolment rate(%) in Netherlands in 2010 to that in 2011?
Keep it short and to the point. 0.98. What is the ratio of the Net enrolment rate(%) of Spain in 2010 to that in 2011?
Provide a succinct answer. 1. What is the ratio of the Net enrolment rate(%) of Netherlands in 2010 to that in 2012?
Give a very brief answer. 0.97. What is the ratio of the Net enrolment rate(%) in Spain in 2010 to that in 2012?
Offer a very short reply. 0.99. What is the ratio of the Net enrolment rate(%) in Japan in 2011 to that in 2012?
Make the answer very short. 1. What is the difference between the highest and the second highest Net enrolment rate(%) of Japan?
Offer a very short reply. 0.06. What is the difference between the highest and the second highest Net enrolment rate(%) in Liechtenstein?
Offer a terse response. 0.24. What is the difference between the highest and the second highest Net enrolment rate(%) in Netherlands?
Ensure brevity in your answer.  0.7. What is the difference between the highest and the second highest Net enrolment rate(%) in Spain?
Give a very brief answer. 0.56. What is the difference between the highest and the lowest Net enrolment rate(%) in Japan?
Give a very brief answer. 1.12. What is the difference between the highest and the lowest Net enrolment rate(%) of Liechtenstein?
Keep it short and to the point. 1.7. What is the difference between the highest and the lowest Net enrolment rate(%) in Netherlands?
Give a very brief answer. 2.74. What is the difference between the highest and the lowest Net enrolment rate(%) of Spain?
Offer a terse response. 2.39. 